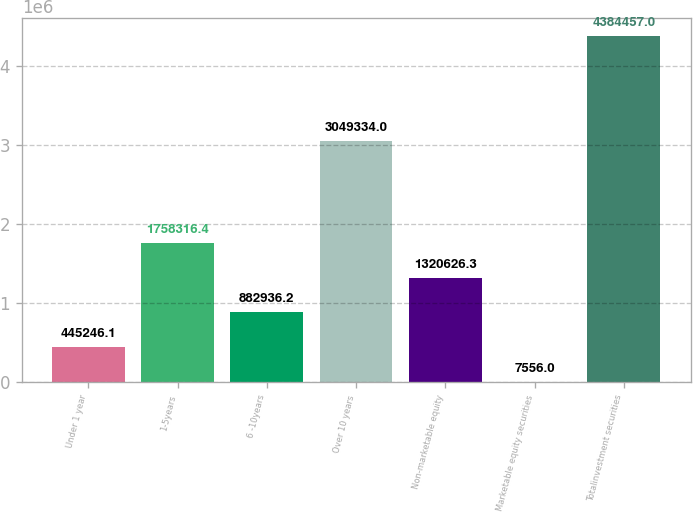Convert chart. <chart><loc_0><loc_0><loc_500><loc_500><bar_chart><fcel>Under 1 year<fcel>1-5years<fcel>6 -10years<fcel>Over 10 years<fcel>Non-marketable equity<fcel>Marketable equity securities<fcel>Totalinvestment securities<nl><fcel>445246<fcel>1.75832e+06<fcel>882936<fcel>3.04933e+06<fcel>1.32063e+06<fcel>7556<fcel>4.38446e+06<nl></chart> 